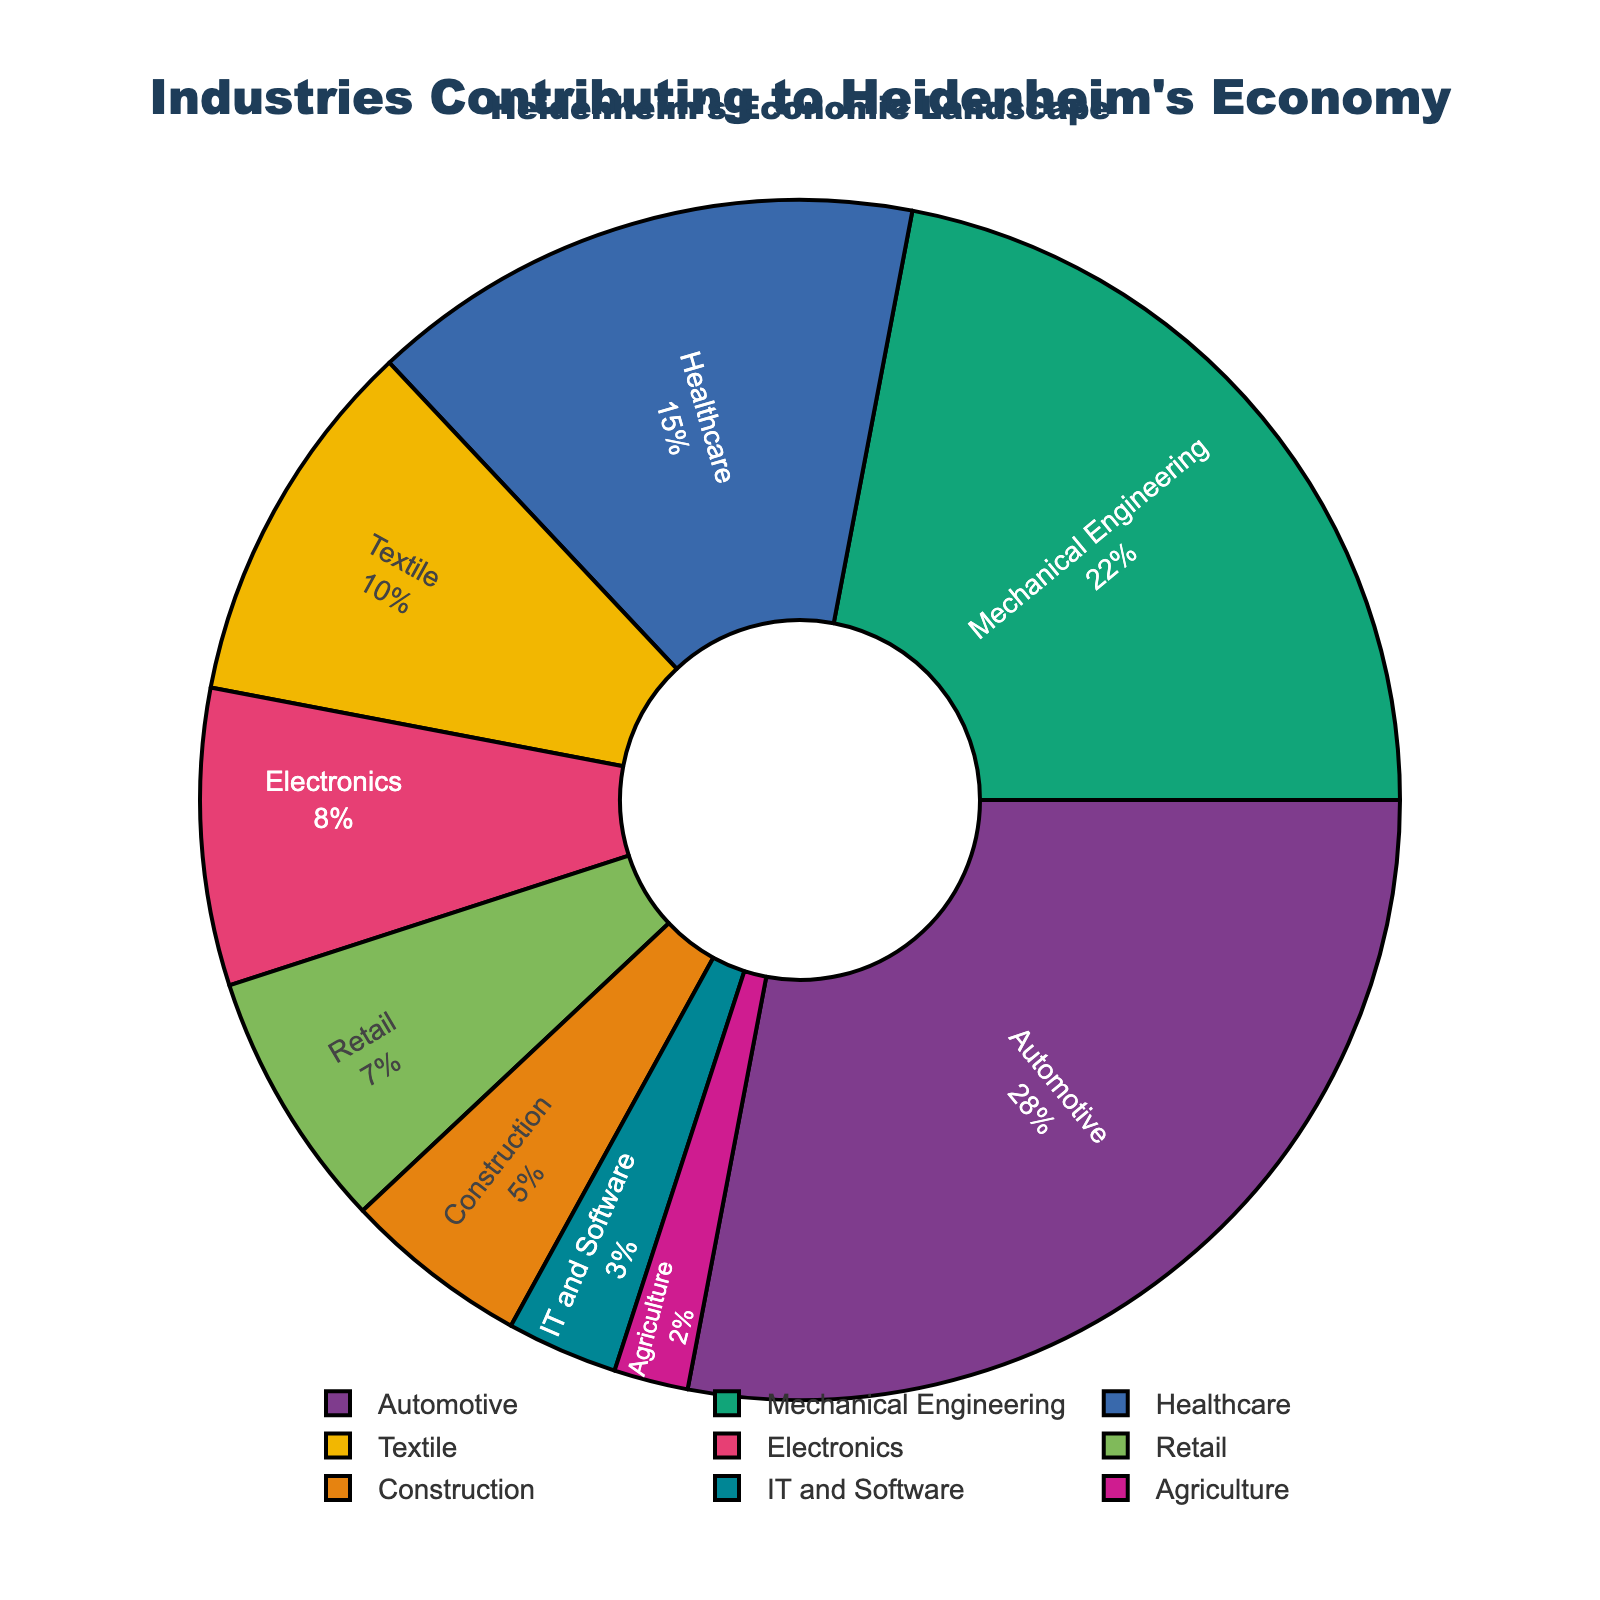What industry contributes the most to Heidenheim's local economy? First, identify the largest sector by looking at the size of the slices in the pie chart. The "Automotive" industry has the largest slice, corresponding to the highest percentage value of 28%.
Answer: Automotive What is the total percentage contribution of the Healthcare and Textile industries? Observe the pie chart to find the slices for Healthcare and Textile industries. Healthcare contributes 15% and Textile 10%. Summing these values gives you 15% + 10% = 25%.
Answer: 25% Which two industries have the closest contributions to Heidenheim's local economy? Compare the sizes of each slice. The percentages for Electronics (8%) and Retail (7%) are closest to each other, with only a 1% difference.
Answer: Electronics and Retail Is the combined contribution of Automotive and Mechanical Engineering industries more than 50%? Automotive contributes 28% and Mechanical Engineering 22%. Sum the two percentages: 28% + 22% = 50%. Since 50% is not more than 50%, the combined contribution equals exactly 50%.
Answer: No Which industry contributes the least to Heidenheim's local economy? Look for the smallest slice in the pie chart. The Agriculture industry has the smallest percentage at 2%.
Answer: Agriculture How does the contribution of the IT and Software industry compare to the Healthcare industry? IT and Software contributes 3%, while Healthcare contributes 15%. The Healthcare contribution is significantly higher. The difference is 15% - 3% = 12%.
Answer: The Healthcare industry contribution is 12% higher What is the combined percentage share of Textile, Electronics, and Retail industries? Identify the percentages for Textile (10%), Electronics (8%), and Retail (7%). Summing these values gives: 10% + 8% + 7% = 25%.
Answer: 25% If you combine the contributions of the Construction and Agriculture industries, what is their total contribution? Construction contributes 5% and Agriculture 2%. Sum these percentages: 5% + 2% = 7%.
Answer: 7% Which industry contributes more, the Mechanical Engineering or Healthcare industry? On the pie chart, Mechanical Engineering contributes 22% while Healthcare contributes 15%. Therefore, Mechanical Engineering contributes more.
Answer: Mechanical Engineering What is the difference in percentage contribution between the Automotive and IT and Software industries? Observe the pie chart: the Automotive industry contributes 28% and IT and Software 3%. Calculate the difference: 28% - 3% = 25%.
Answer: 25% 